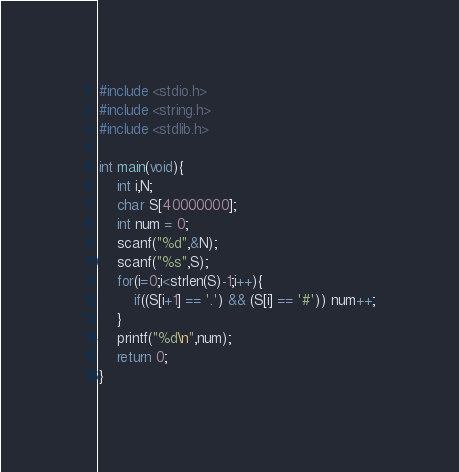<code> <loc_0><loc_0><loc_500><loc_500><_C_>#include <stdio.h>
#include <string.h>
#include <stdlib.h>

int main(void){
    int i,N;
    char S[40000000];
    int num = 0;
    scanf("%d",&N);
    scanf("%s",S);
    for(i=0;i<strlen(S)-1;i++){
        if((S[i+1] == '.') && (S[i] == '#')) num++;
    }
    printf("%d\n",num);
    return 0;
}</code> 